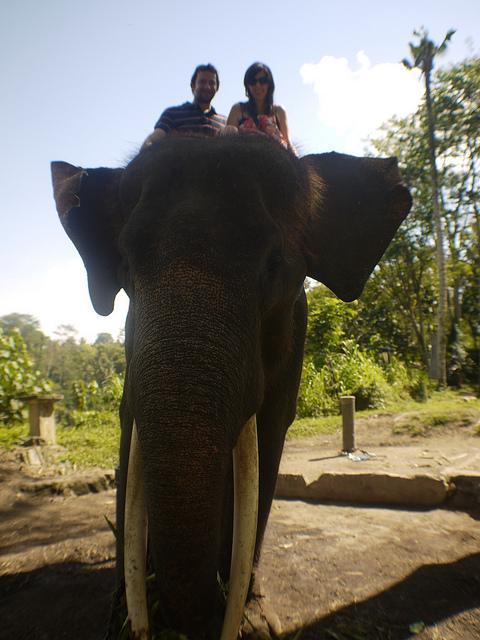How many people can be seen?
Give a very brief answer. 2. How many skateboards are not being ridden?
Give a very brief answer. 0. 